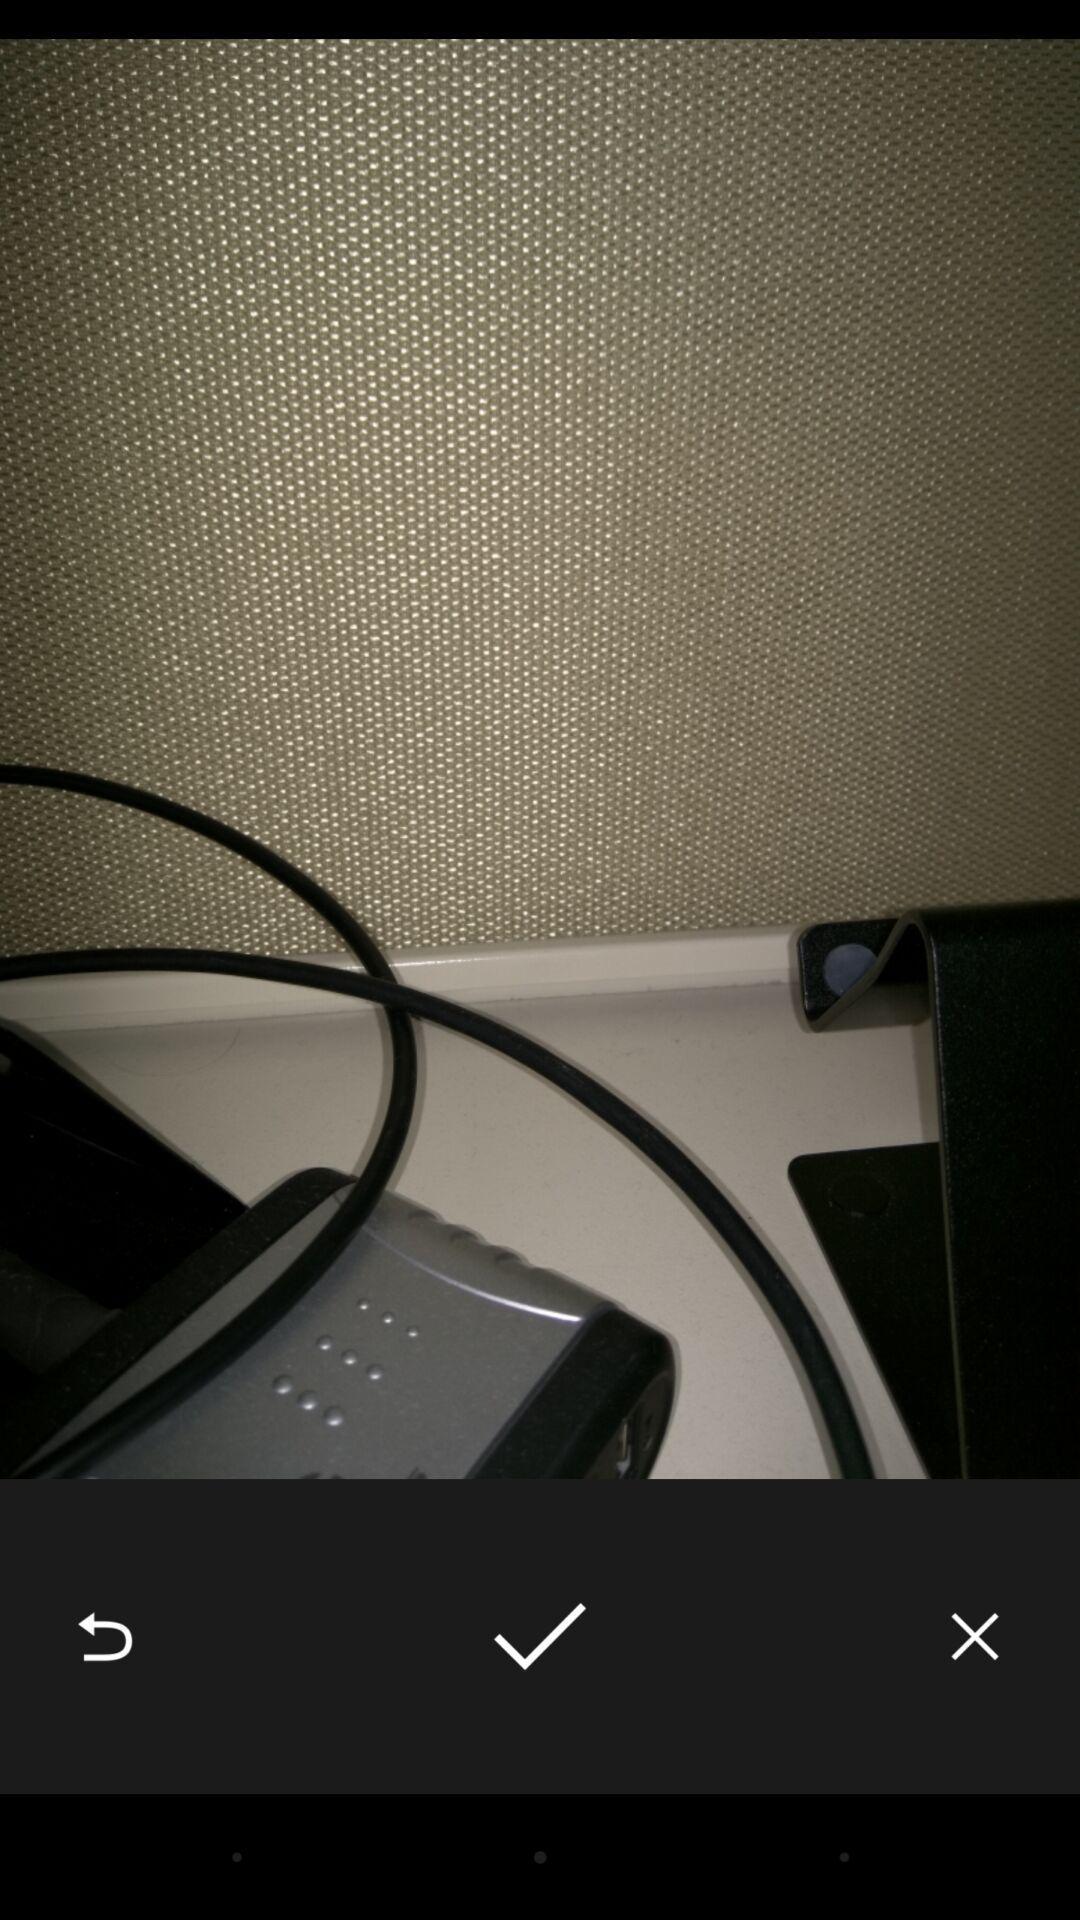Provide a textual representation of this image. Screen displaying an image with multiple controls. 